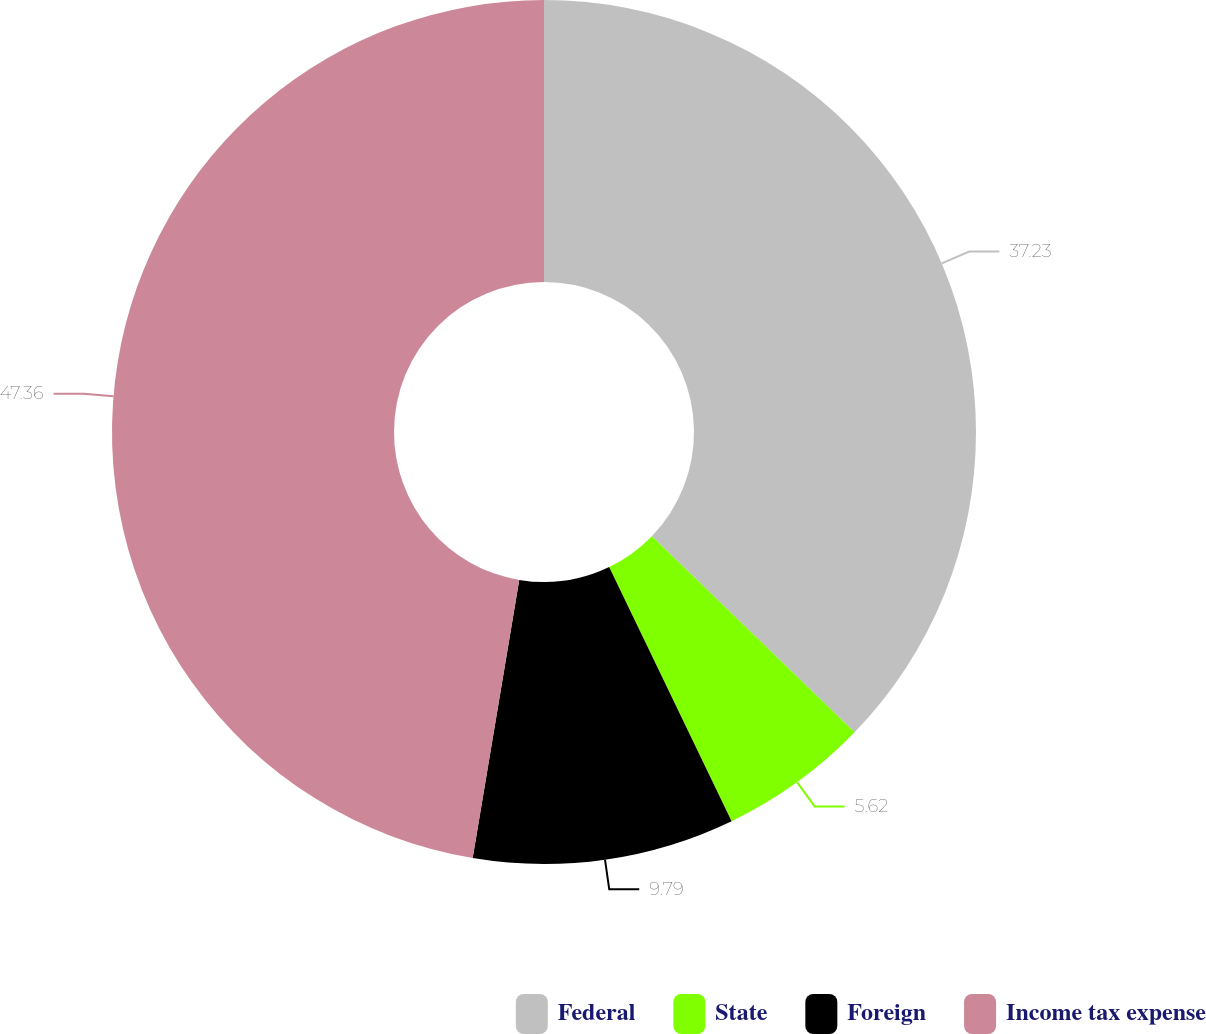<chart> <loc_0><loc_0><loc_500><loc_500><pie_chart><fcel>Federal<fcel>State<fcel>Foreign<fcel>Income tax expense<nl><fcel>37.23%<fcel>5.62%<fcel>9.79%<fcel>47.36%<nl></chart> 